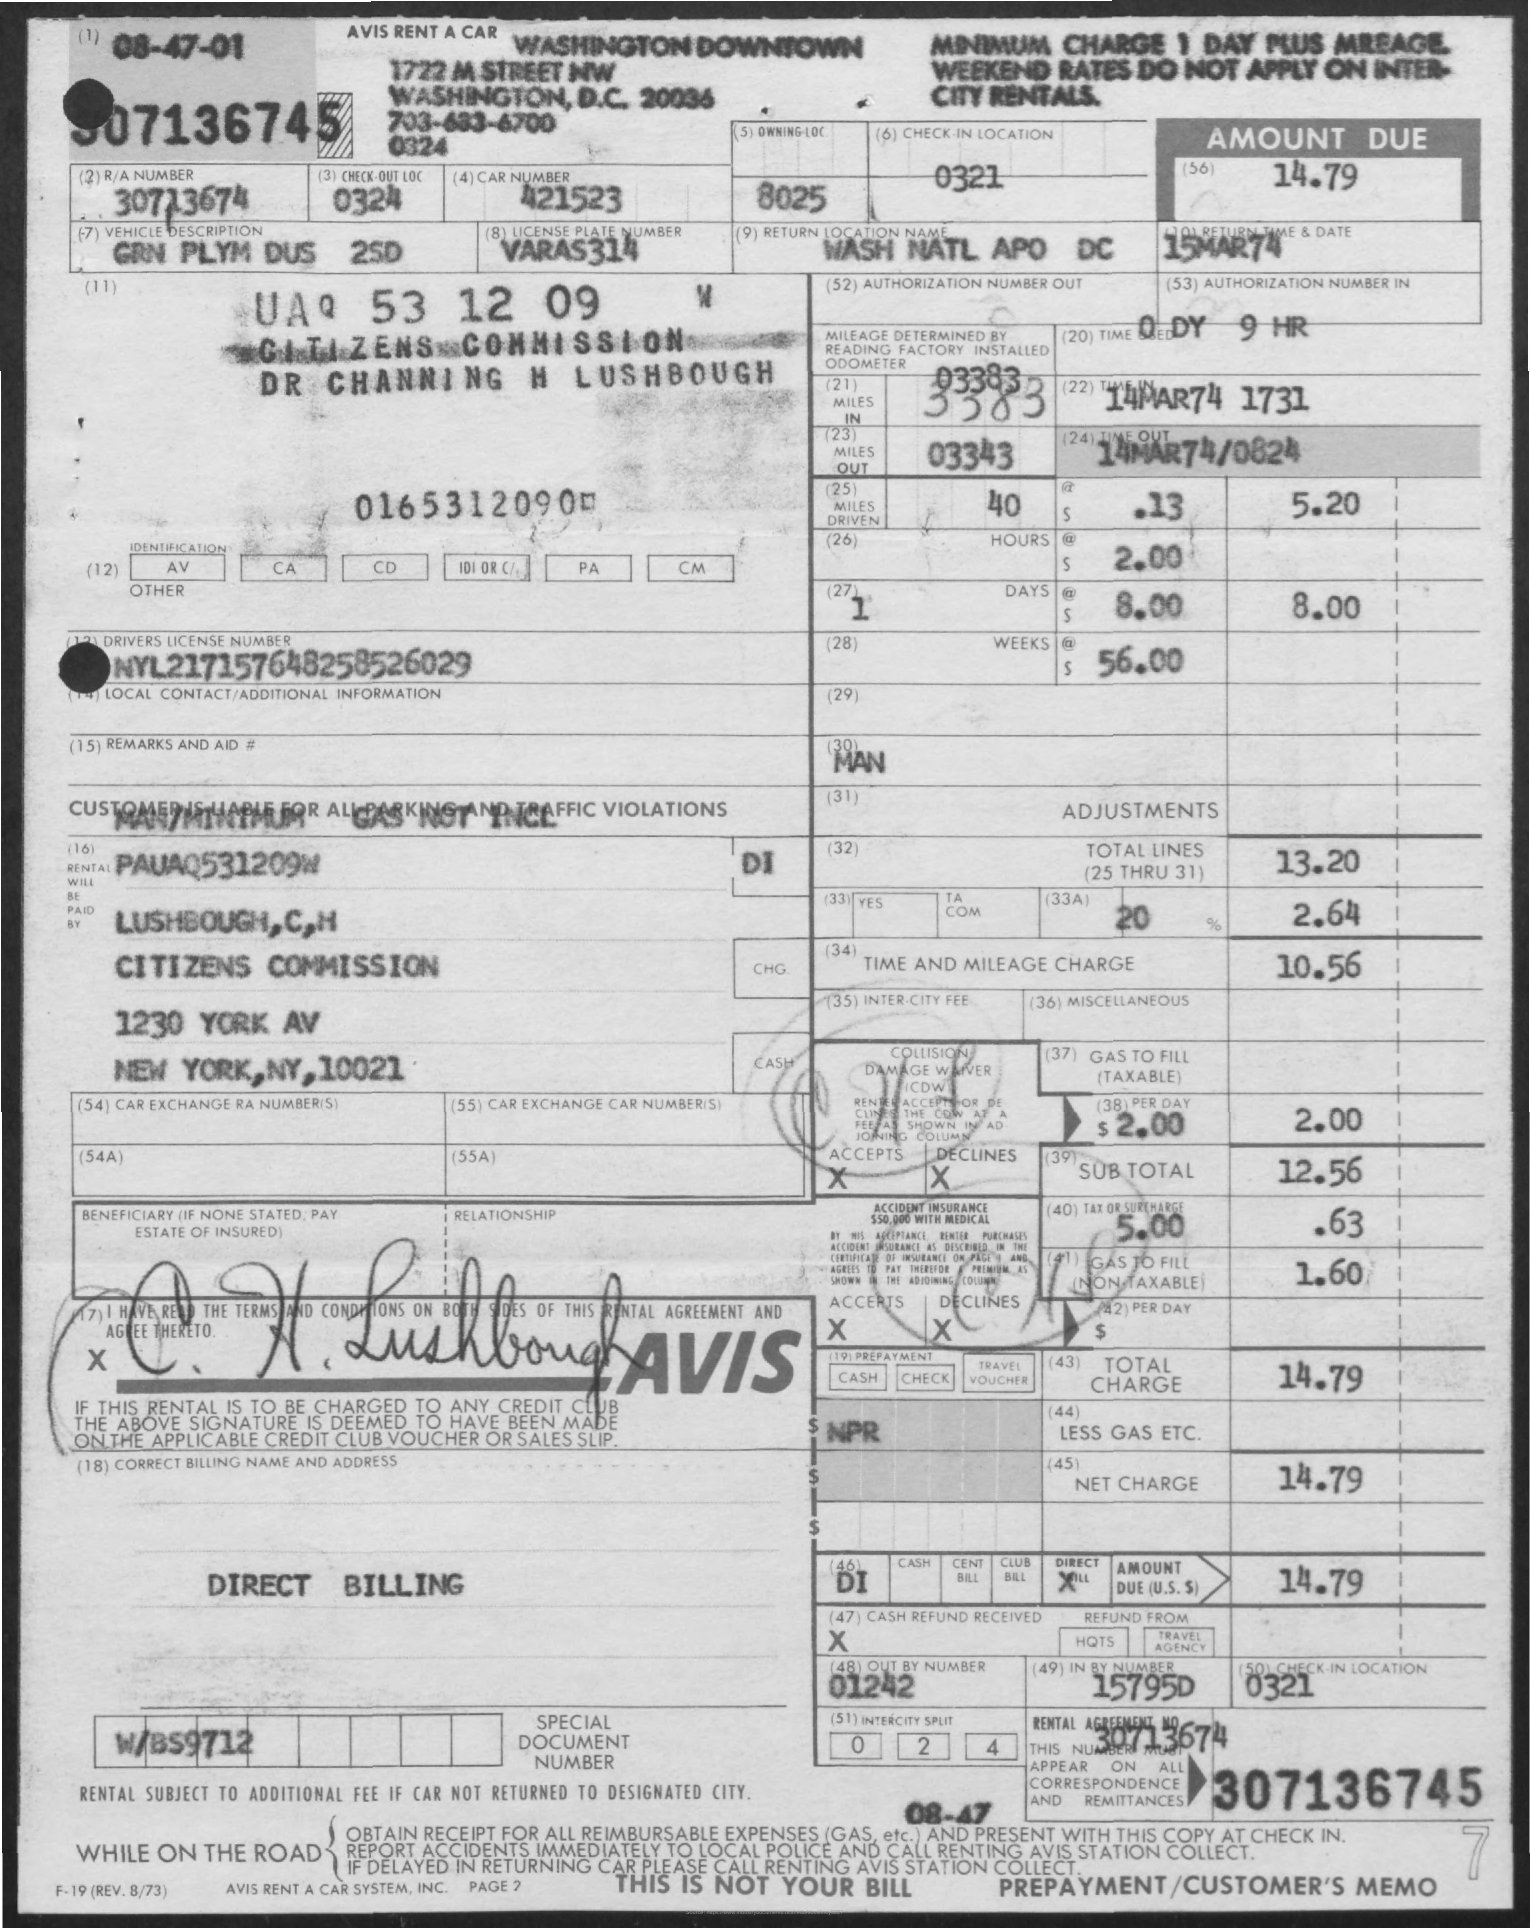What is the address listed on this rental agreement? The address listed is 1230 York Avenue, New York, NY, 10021. 